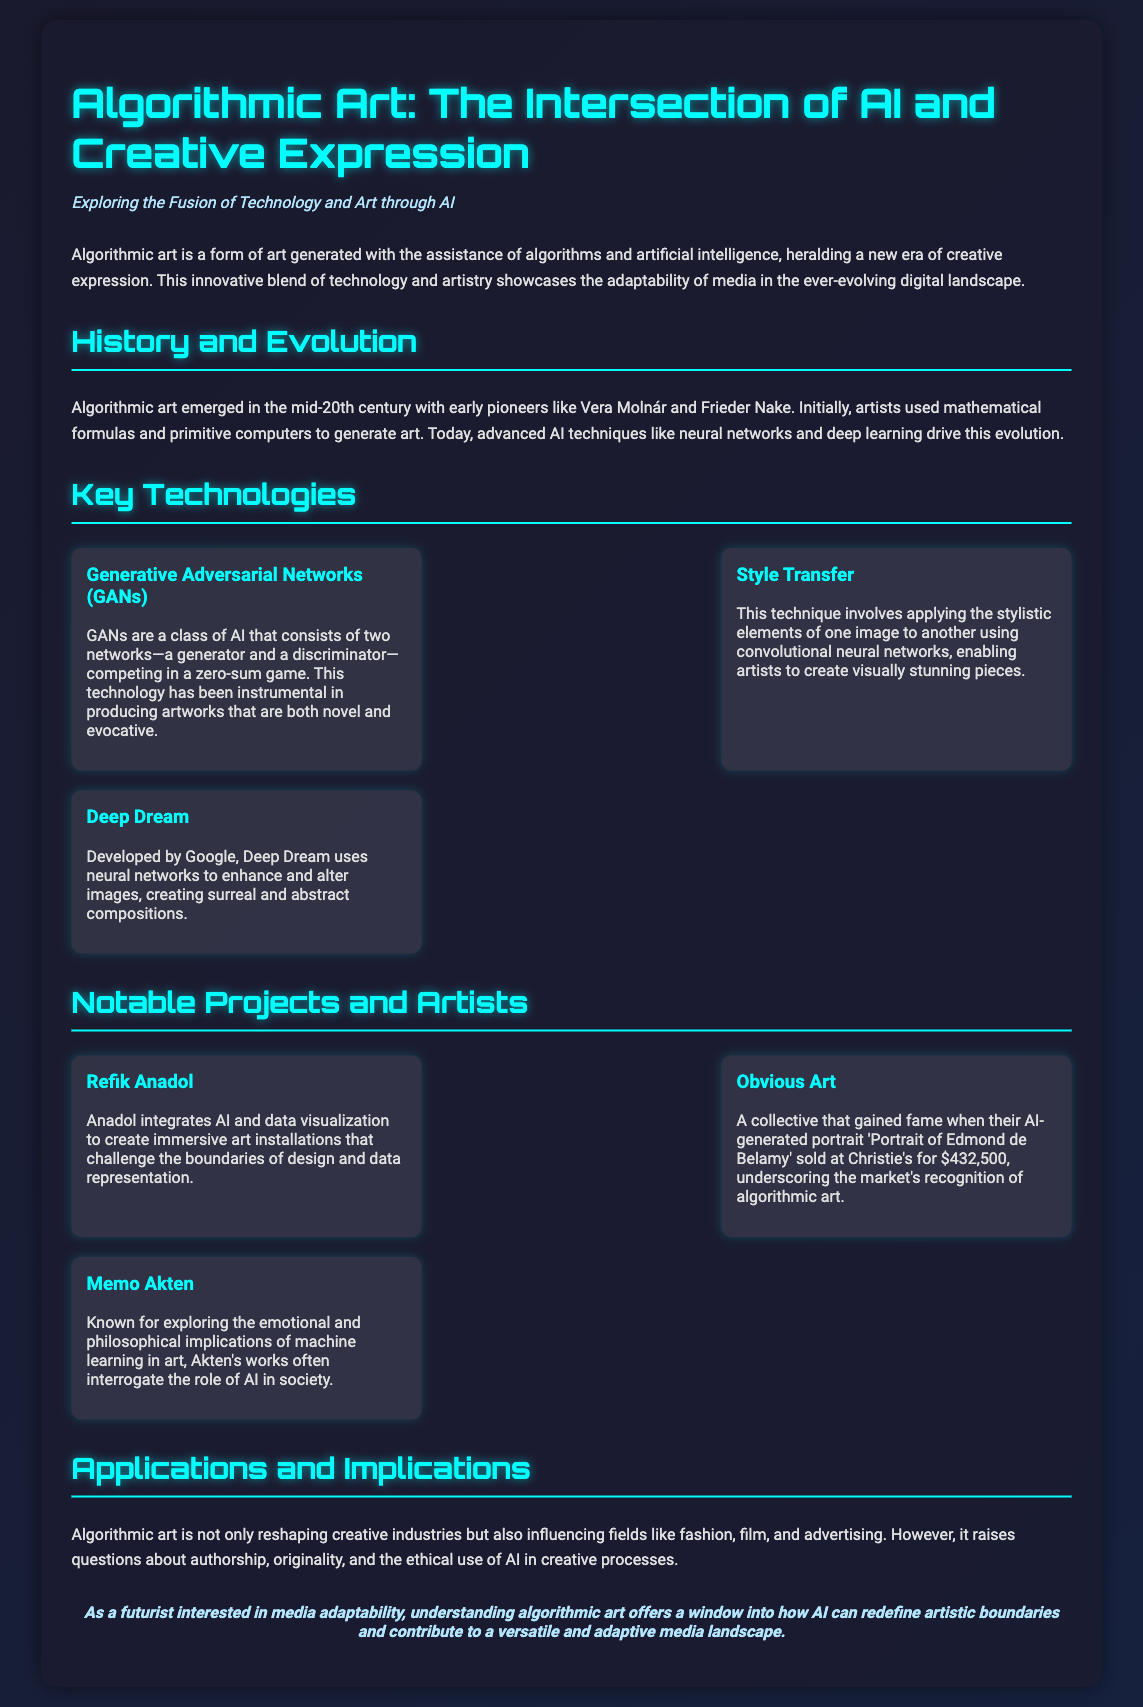What is the title of the presentation? The title is explicitly stated as the first line in the document.
Answer: Algorithmic Art: The Intersection of AI and Creative Expression Who are two early pioneers of algorithmic art mentioned? The document specifies early pioneers list that includes Vera Molnár and Frieder Nake.
Answer: Vera Molnár, Frieder Nake What technology is instrumental in producing novel artworks? The document identifies this technology as a class of AI that includes a generator and a discriminator.
Answer: Generative Adversarial Networks (GANs) Which project sold an AI-generated portrait at Christie's? This specific project is highlighted in the document as having gained fame through a notable sale.
Answer: Obvious Art What technique applies the stylistic elements of one image to another? The document refers to this technique that uses convolutional neural networks.
Answer: Style Transfer How does Refik Anadol's work challenge artistic boundaries? The document articulates how Anadol's work interacts with design and data representation.
Answer: Immersive art installations What are some fields influenced by algorithmic art? The document lists several fields impacted by this form of art, reflecting its versatility.
Answer: Fashion, film, advertising What question does algorithmic art raise about AI? The document discusses concerns arising from the incorporation of AI in the creative process.
Answer: Authorship, originality, ethical use 